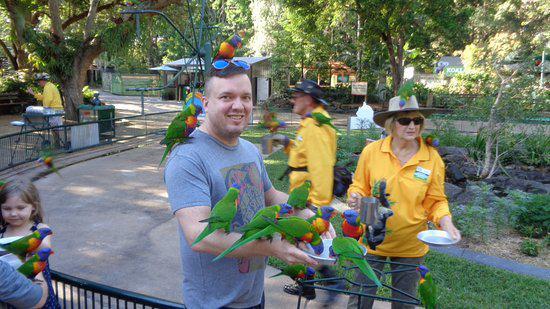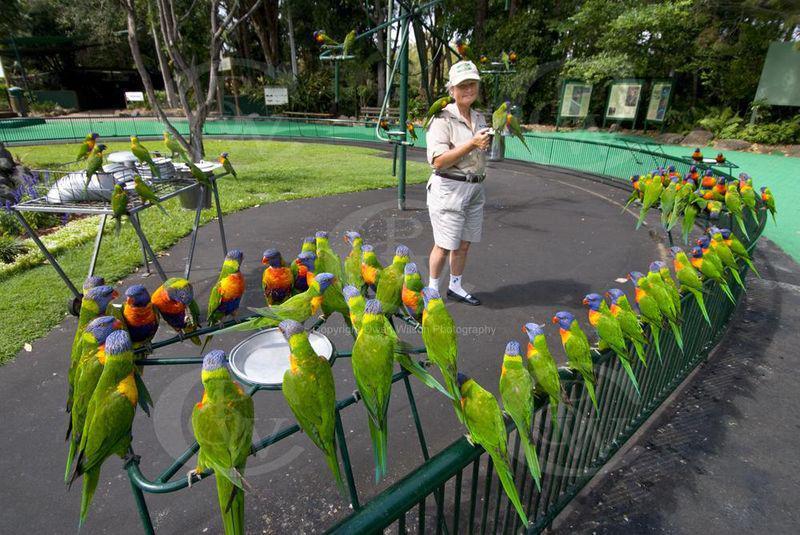The first image is the image on the left, the second image is the image on the right. Given the left and right images, does the statement "The birds are only drinking water in one of the iages." hold true? Answer yes or no. Yes. The first image is the image on the left, the second image is the image on the right. Assess this claim about the two images: "birds are standing on a green platform with a bowl in the center on a blacktop sidewalk". Correct or not? Answer yes or no. Yes. 